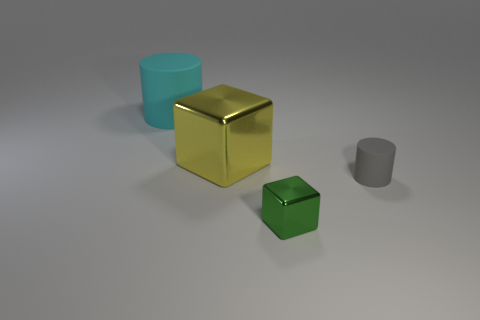Add 2 yellow metallic things. How many objects exist? 6 Add 2 small shiny objects. How many small shiny objects are left? 3 Add 2 yellow metallic objects. How many yellow metallic objects exist? 3 Subtract 0 brown cubes. How many objects are left? 4 Subtract all yellow blocks. Subtract all large gray matte cubes. How many objects are left? 3 